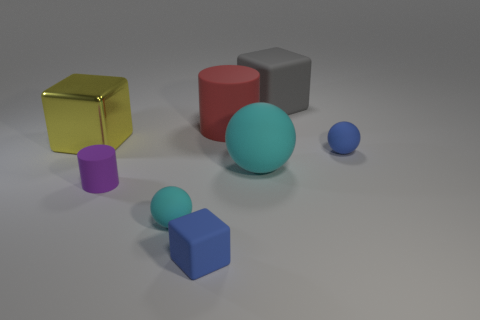Subtract all tiny cyan balls. How many balls are left? 2 Subtract all yellow cylinders. How many cyan balls are left? 2 Add 1 red rubber objects. How many objects exist? 9 Subtract all purple cylinders. How many cylinders are left? 1 Subtract 1 blocks. How many blocks are left? 2 Subtract all cylinders. How many objects are left? 6 Subtract 1 blue blocks. How many objects are left? 7 Subtract all purple balls. Subtract all red cylinders. How many balls are left? 3 Subtract all yellow metallic objects. Subtract all large red matte cylinders. How many objects are left? 6 Add 1 small purple cylinders. How many small purple cylinders are left? 2 